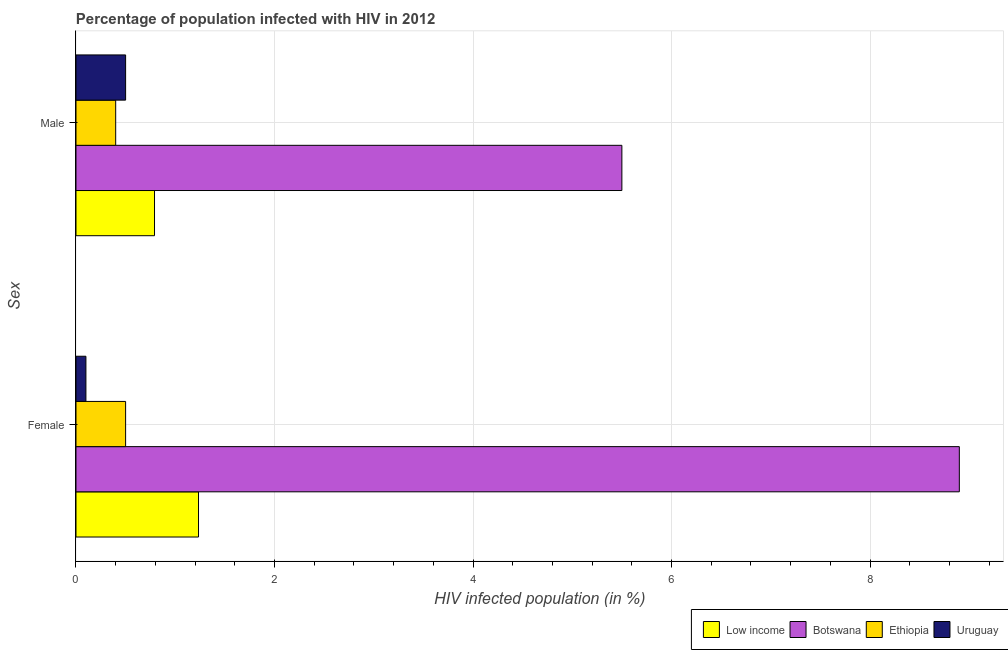How many groups of bars are there?
Offer a very short reply. 2. Are the number of bars per tick equal to the number of legend labels?
Give a very brief answer. Yes. Are the number of bars on each tick of the Y-axis equal?
Your response must be concise. Yes. How many bars are there on the 2nd tick from the top?
Ensure brevity in your answer.  4. Across all countries, what is the minimum percentage of males who are infected with hiv?
Make the answer very short. 0.4. In which country was the percentage of females who are infected with hiv maximum?
Offer a terse response. Botswana. In which country was the percentage of females who are infected with hiv minimum?
Make the answer very short. Uruguay. What is the total percentage of males who are infected with hiv in the graph?
Keep it short and to the point. 7.19. What is the difference between the percentage of females who are infected with hiv in Low income and that in Ethiopia?
Your answer should be compact. 0.73. What is the difference between the percentage of males who are infected with hiv in Botswana and the percentage of females who are infected with hiv in Ethiopia?
Give a very brief answer. 5. What is the average percentage of females who are infected with hiv per country?
Keep it short and to the point. 2.68. What is the difference between the percentage of males who are infected with hiv and percentage of females who are infected with hiv in Botswana?
Ensure brevity in your answer.  -3.4. Is the percentage of females who are infected with hiv in Uruguay less than that in Botswana?
Your answer should be very brief. Yes. What does the 2nd bar from the top in Male represents?
Keep it short and to the point. Ethiopia. How many bars are there?
Provide a short and direct response. 8. How many countries are there in the graph?
Make the answer very short. 4. Does the graph contain grids?
Offer a very short reply. Yes. What is the title of the graph?
Offer a terse response. Percentage of population infected with HIV in 2012. Does "Dominica" appear as one of the legend labels in the graph?
Provide a succinct answer. No. What is the label or title of the X-axis?
Provide a succinct answer. HIV infected population (in %). What is the label or title of the Y-axis?
Give a very brief answer. Sex. What is the HIV infected population (in %) of Low income in Female?
Provide a succinct answer. 1.23. What is the HIV infected population (in %) in Botswana in Female?
Provide a short and direct response. 8.9. What is the HIV infected population (in %) of Low income in Male?
Provide a succinct answer. 0.79. What is the HIV infected population (in %) in Uruguay in Male?
Offer a terse response. 0.5. Across all Sex, what is the maximum HIV infected population (in %) in Low income?
Offer a very short reply. 1.23. Across all Sex, what is the maximum HIV infected population (in %) in Botswana?
Give a very brief answer. 8.9. Across all Sex, what is the minimum HIV infected population (in %) in Low income?
Keep it short and to the point. 0.79. Across all Sex, what is the minimum HIV infected population (in %) of Uruguay?
Give a very brief answer. 0.1. What is the total HIV infected population (in %) of Low income in the graph?
Your response must be concise. 2.03. What is the total HIV infected population (in %) in Botswana in the graph?
Your answer should be compact. 14.4. What is the total HIV infected population (in %) of Ethiopia in the graph?
Your answer should be compact. 0.9. What is the total HIV infected population (in %) of Uruguay in the graph?
Keep it short and to the point. 0.6. What is the difference between the HIV infected population (in %) in Low income in Female and that in Male?
Your response must be concise. 0.44. What is the difference between the HIV infected population (in %) in Botswana in Female and that in Male?
Offer a terse response. 3.4. What is the difference between the HIV infected population (in %) in Low income in Female and the HIV infected population (in %) in Botswana in Male?
Offer a terse response. -4.27. What is the difference between the HIV infected population (in %) in Low income in Female and the HIV infected population (in %) in Ethiopia in Male?
Provide a succinct answer. 0.83. What is the difference between the HIV infected population (in %) in Low income in Female and the HIV infected population (in %) in Uruguay in Male?
Your response must be concise. 0.73. What is the difference between the HIV infected population (in %) of Botswana in Female and the HIV infected population (in %) of Ethiopia in Male?
Ensure brevity in your answer.  8.5. What is the average HIV infected population (in %) of Low income per Sex?
Your answer should be very brief. 1.01. What is the average HIV infected population (in %) of Ethiopia per Sex?
Offer a very short reply. 0.45. What is the difference between the HIV infected population (in %) of Low income and HIV infected population (in %) of Botswana in Female?
Your answer should be very brief. -7.67. What is the difference between the HIV infected population (in %) of Low income and HIV infected population (in %) of Ethiopia in Female?
Provide a short and direct response. 0.73. What is the difference between the HIV infected population (in %) in Low income and HIV infected population (in %) in Uruguay in Female?
Your answer should be very brief. 1.13. What is the difference between the HIV infected population (in %) in Botswana and HIV infected population (in %) in Ethiopia in Female?
Offer a terse response. 8.4. What is the difference between the HIV infected population (in %) of Botswana and HIV infected population (in %) of Uruguay in Female?
Your response must be concise. 8.8. What is the difference between the HIV infected population (in %) in Ethiopia and HIV infected population (in %) in Uruguay in Female?
Give a very brief answer. 0.4. What is the difference between the HIV infected population (in %) in Low income and HIV infected population (in %) in Botswana in Male?
Your answer should be compact. -4.71. What is the difference between the HIV infected population (in %) of Low income and HIV infected population (in %) of Ethiopia in Male?
Your answer should be compact. 0.39. What is the difference between the HIV infected population (in %) of Low income and HIV infected population (in %) of Uruguay in Male?
Give a very brief answer. 0.29. What is the ratio of the HIV infected population (in %) of Low income in Female to that in Male?
Provide a short and direct response. 1.56. What is the ratio of the HIV infected population (in %) of Botswana in Female to that in Male?
Give a very brief answer. 1.62. What is the ratio of the HIV infected population (in %) of Ethiopia in Female to that in Male?
Ensure brevity in your answer.  1.25. What is the difference between the highest and the second highest HIV infected population (in %) of Low income?
Provide a short and direct response. 0.44. What is the difference between the highest and the second highest HIV infected population (in %) in Ethiopia?
Your response must be concise. 0.1. What is the difference between the highest and the lowest HIV infected population (in %) in Low income?
Your response must be concise. 0.44. What is the difference between the highest and the lowest HIV infected population (in %) of Botswana?
Provide a short and direct response. 3.4. What is the difference between the highest and the lowest HIV infected population (in %) in Uruguay?
Give a very brief answer. 0.4. 